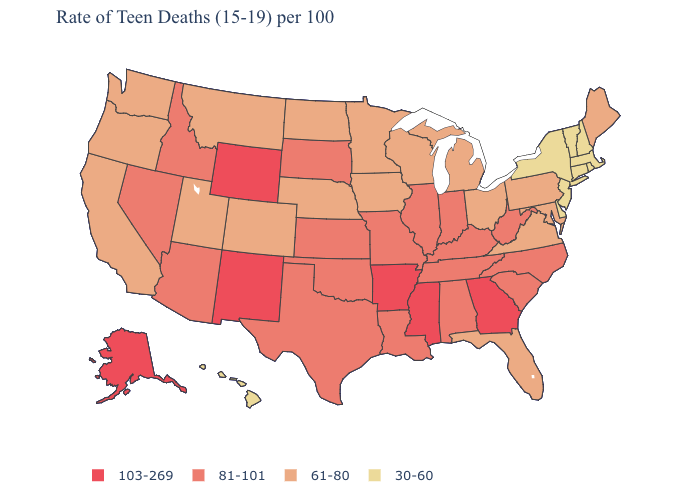Among the states that border Michigan , which have the lowest value?
Be succinct. Ohio, Wisconsin. Name the states that have a value in the range 30-60?
Short answer required. Connecticut, Delaware, Hawaii, Massachusetts, New Hampshire, New Jersey, New York, Rhode Island, Vermont. Which states have the highest value in the USA?
Be succinct. Alaska, Arkansas, Georgia, Mississippi, New Mexico, Wyoming. What is the lowest value in states that border Massachusetts?
Answer briefly. 30-60. How many symbols are there in the legend?
Concise answer only. 4. Name the states that have a value in the range 30-60?
Short answer required. Connecticut, Delaware, Hawaii, Massachusetts, New Hampshire, New Jersey, New York, Rhode Island, Vermont. Name the states that have a value in the range 81-101?
Short answer required. Alabama, Arizona, Idaho, Illinois, Indiana, Kansas, Kentucky, Louisiana, Missouri, Nevada, North Carolina, Oklahoma, South Carolina, South Dakota, Tennessee, Texas, West Virginia. Name the states that have a value in the range 81-101?
Answer briefly. Alabama, Arizona, Idaho, Illinois, Indiana, Kansas, Kentucky, Louisiana, Missouri, Nevada, North Carolina, Oklahoma, South Carolina, South Dakota, Tennessee, Texas, West Virginia. What is the highest value in the USA?
Concise answer only. 103-269. Does Indiana have the lowest value in the MidWest?
Keep it brief. No. Name the states that have a value in the range 103-269?
Concise answer only. Alaska, Arkansas, Georgia, Mississippi, New Mexico, Wyoming. What is the lowest value in the USA?
Be succinct. 30-60. Name the states that have a value in the range 61-80?
Give a very brief answer. California, Colorado, Florida, Iowa, Maine, Maryland, Michigan, Minnesota, Montana, Nebraska, North Dakota, Ohio, Oregon, Pennsylvania, Utah, Virginia, Washington, Wisconsin. Does Idaho have a higher value than Pennsylvania?
Give a very brief answer. Yes. What is the value of Wyoming?
Short answer required. 103-269. 